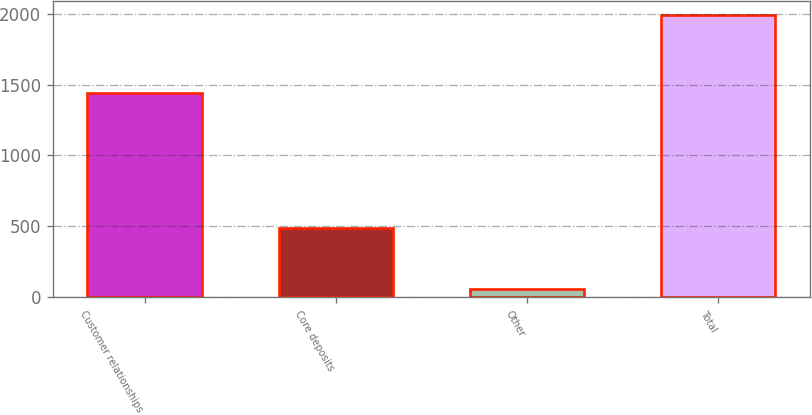<chart> <loc_0><loc_0><loc_500><loc_500><bar_chart><fcel>Customer relationships<fcel>Core deposits<fcel>Other<fcel>Total<nl><fcel>1442<fcel>489<fcel>59<fcel>1990<nl></chart> 